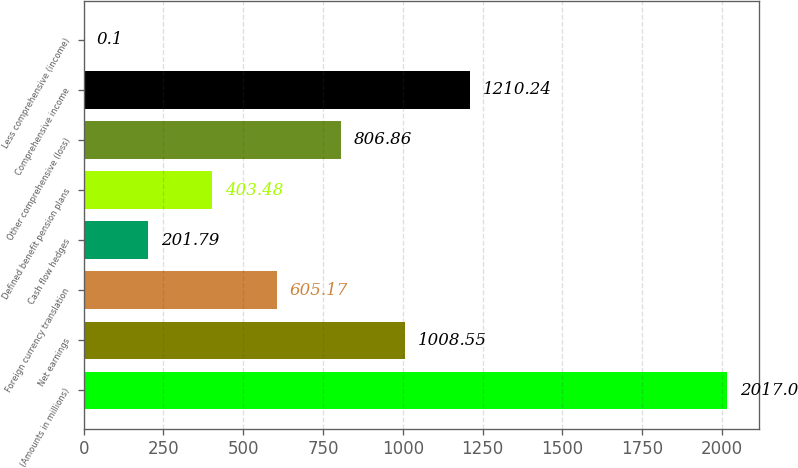Convert chart. <chart><loc_0><loc_0><loc_500><loc_500><bar_chart><fcel>(Amounts in millions)<fcel>Net earnings<fcel>Foreign currency translation<fcel>Cash flow hedges<fcel>Defined benefit pension plans<fcel>Other comprehensive (loss)<fcel>Comprehensive income<fcel>Less comprehensive (income)<nl><fcel>2017<fcel>1008.55<fcel>605.17<fcel>201.79<fcel>403.48<fcel>806.86<fcel>1210.24<fcel>0.1<nl></chart> 